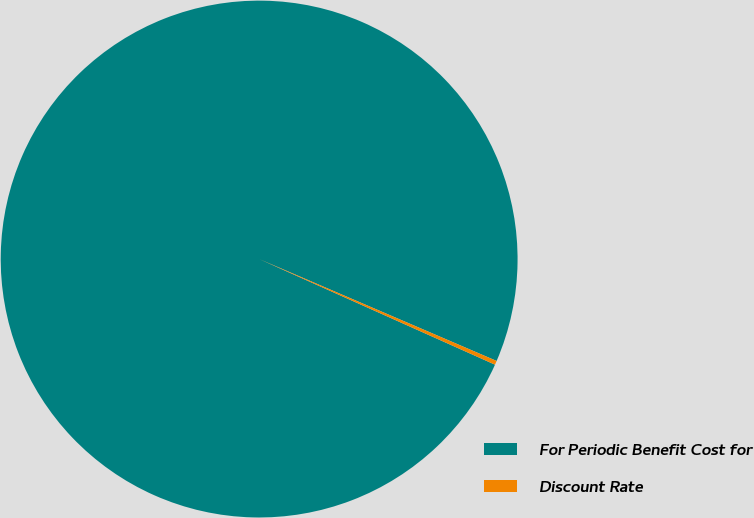Convert chart. <chart><loc_0><loc_0><loc_500><loc_500><pie_chart><fcel>For Periodic Benefit Cost for<fcel>Discount Rate<nl><fcel>99.75%<fcel>0.25%<nl></chart> 